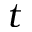<formula> <loc_0><loc_0><loc_500><loc_500>t</formula> 